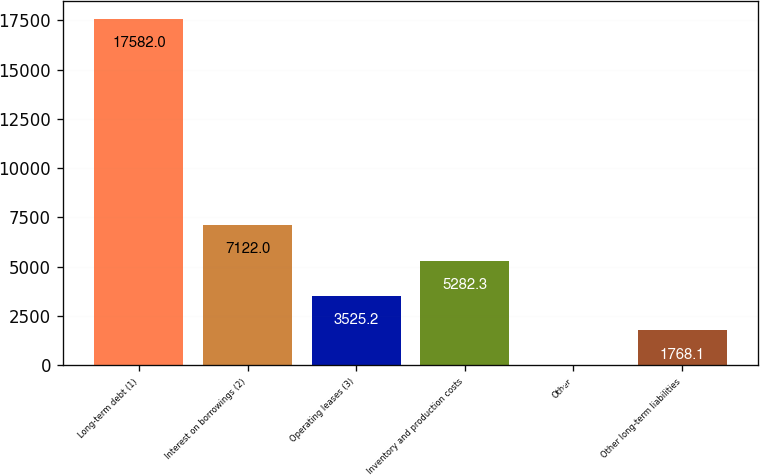Convert chart. <chart><loc_0><loc_0><loc_500><loc_500><bar_chart><fcel>Long-term debt (1)<fcel>Interest on borrowings (2)<fcel>Operating leases (3)<fcel>Inventory and production costs<fcel>Other<fcel>Other long-term liabilities<nl><fcel>17582<fcel>7122<fcel>3525.2<fcel>5282.3<fcel>11<fcel>1768.1<nl></chart> 